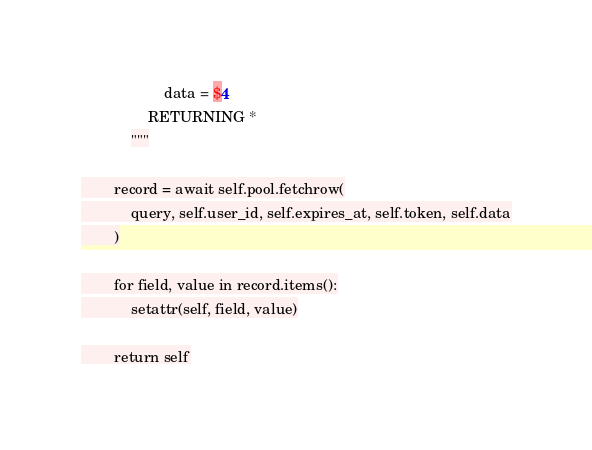<code> <loc_0><loc_0><loc_500><loc_500><_Python_>                    data = $4
                RETURNING *
            """

        record = await self.pool.fetchrow(
            query, self.user_id, self.expires_at, self.token, self.data
        )

        for field, value in record.items():
            setattr(self, field, value)

        return self
</code> 